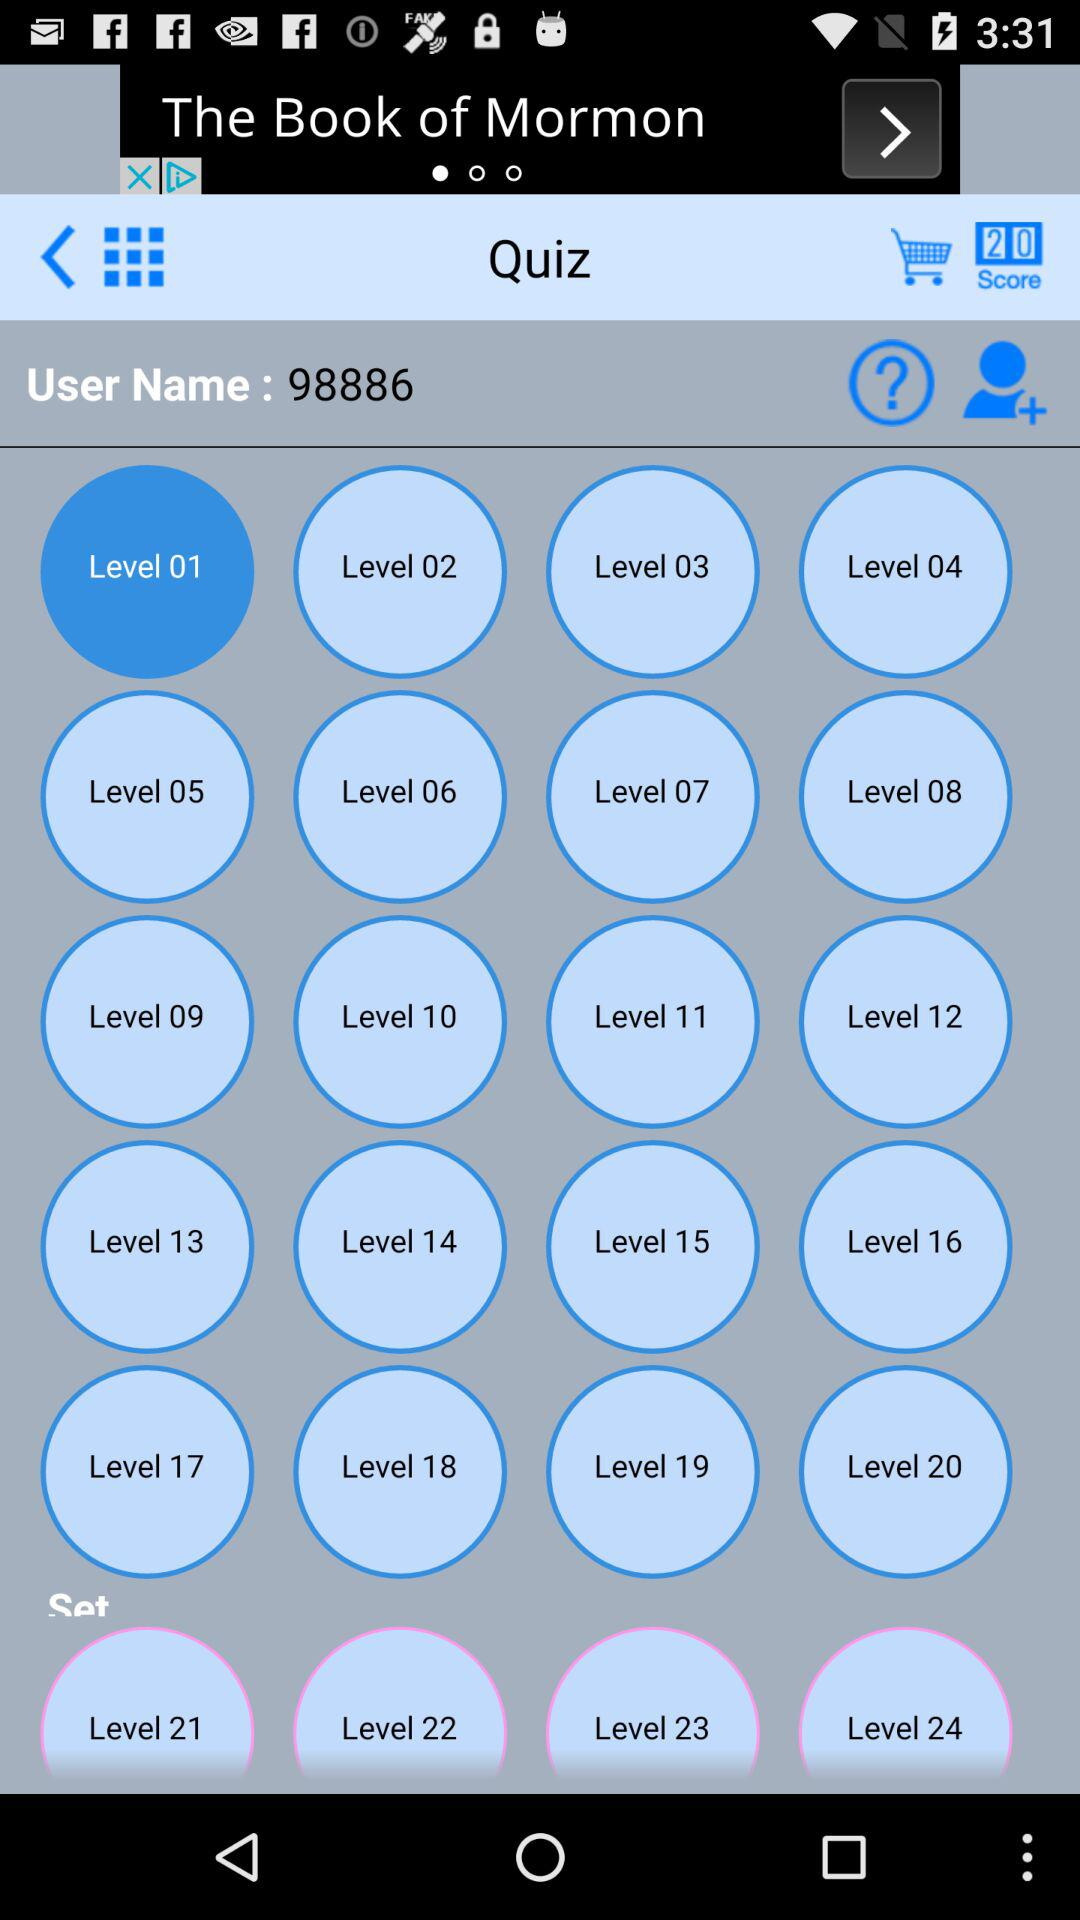Where is "The Book of Mormon" being performed?
When the provided information is insufficient, respond with <no answer>. <no answer> 